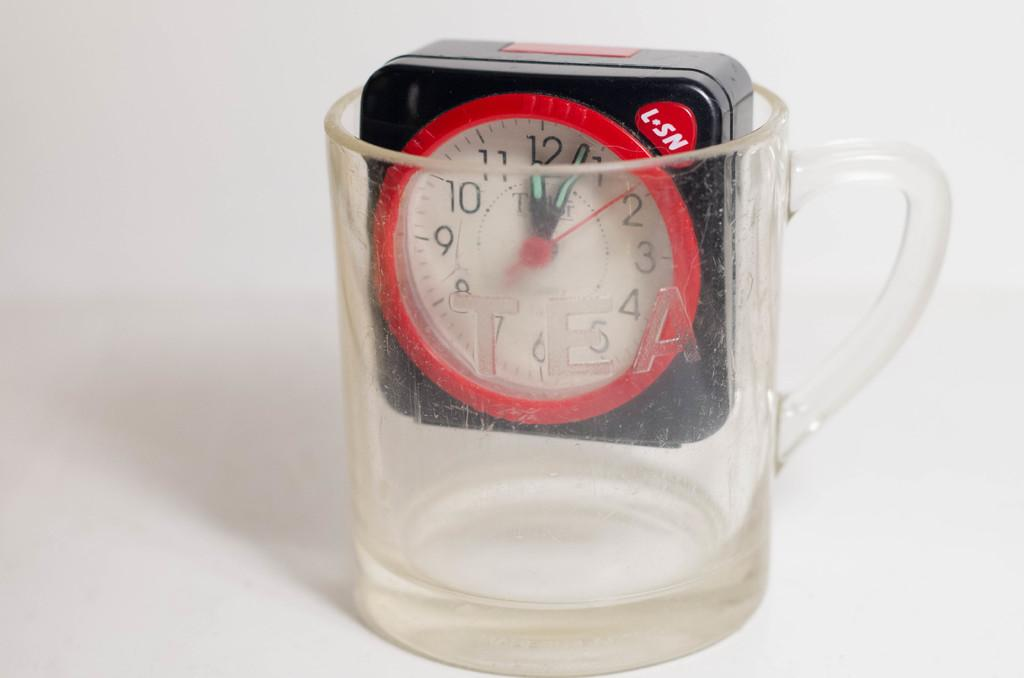<image>
Give a short and clear explanation of the subsequent image. a clock  labelled L-SN in a glass 